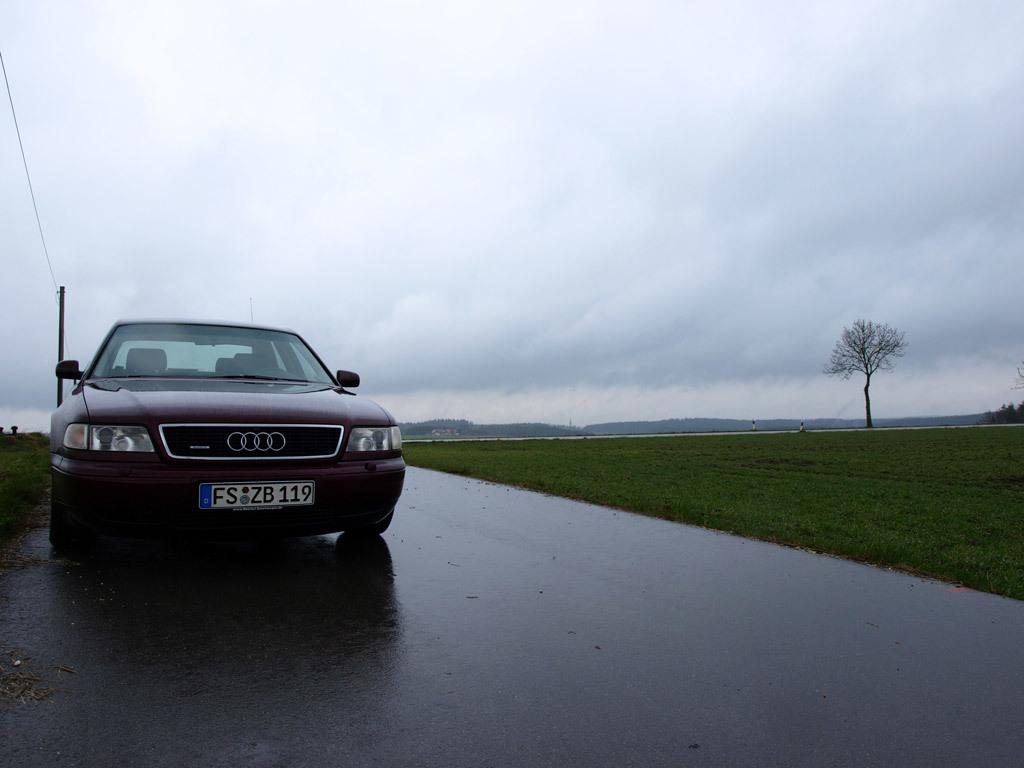Provide a one-sentence caption for the provided image. An Audi with a liscence plate reading FS ZB 119. 